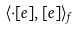Convert formula to latex. <formula><loc_0><loc_0><loc_500><loc_500>\langle \cdot [ e ] , [ e ] \rangle _ { f }</formula> 